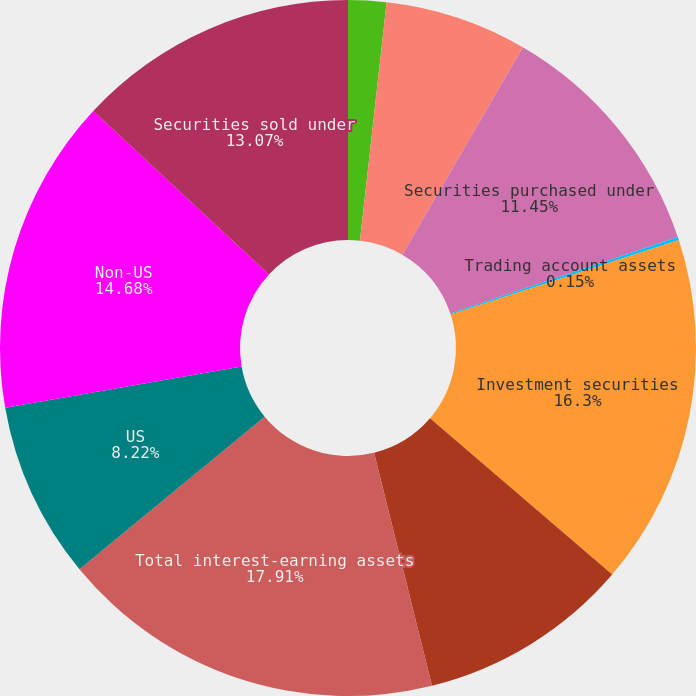Convert chart. <chart><loc_0><loc_0><loc_500><loc_500><pie_chart><fcel>Years ended December 31<fcel>Interest-bearing deposits with<fcel>Securities purchased under<fcel>Trading account assets<fcel>Investment securities<fcel>Loans and leases (2)<fcel>Total interest-earning assets<fcel>US<fcel>Non-US<fcel>Securities sold under<nl><fcel>1.77%<fcel>6.61%<fcel>11.45%<fcel>0.15%<fcel>16.3%<fcel>9.84%<fcel>17.91%<fcel>8.22%<fcel>14.68%<fcel>13.07%<nl></chart> 